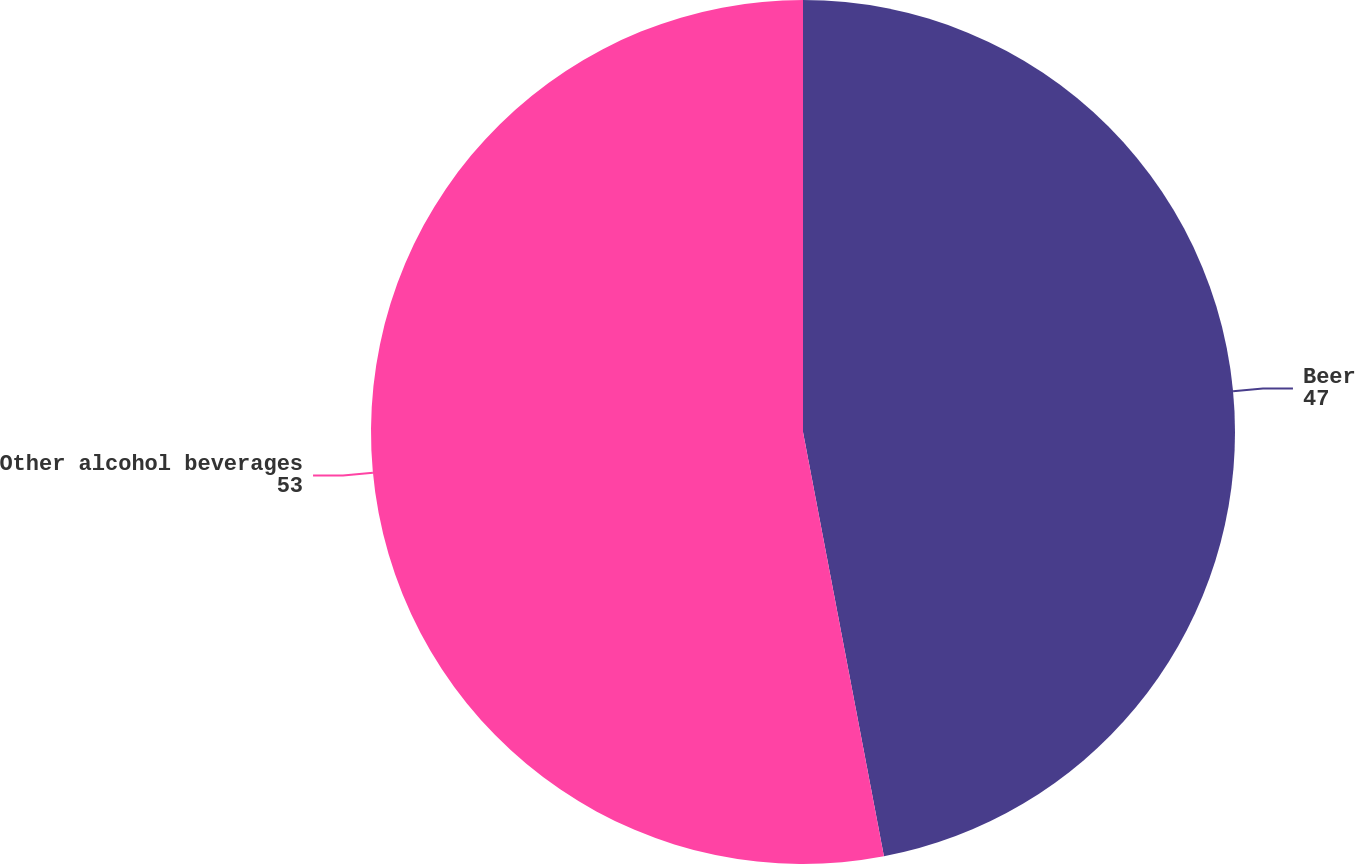Convert chart. <chart><loc_0><loc_0><loc_500><loc_500><pie_chart><fcel>Beer<fcel>Other alcohol beverages<nl><fcel>47.0%<fcel>53.0%<nl></chart> 